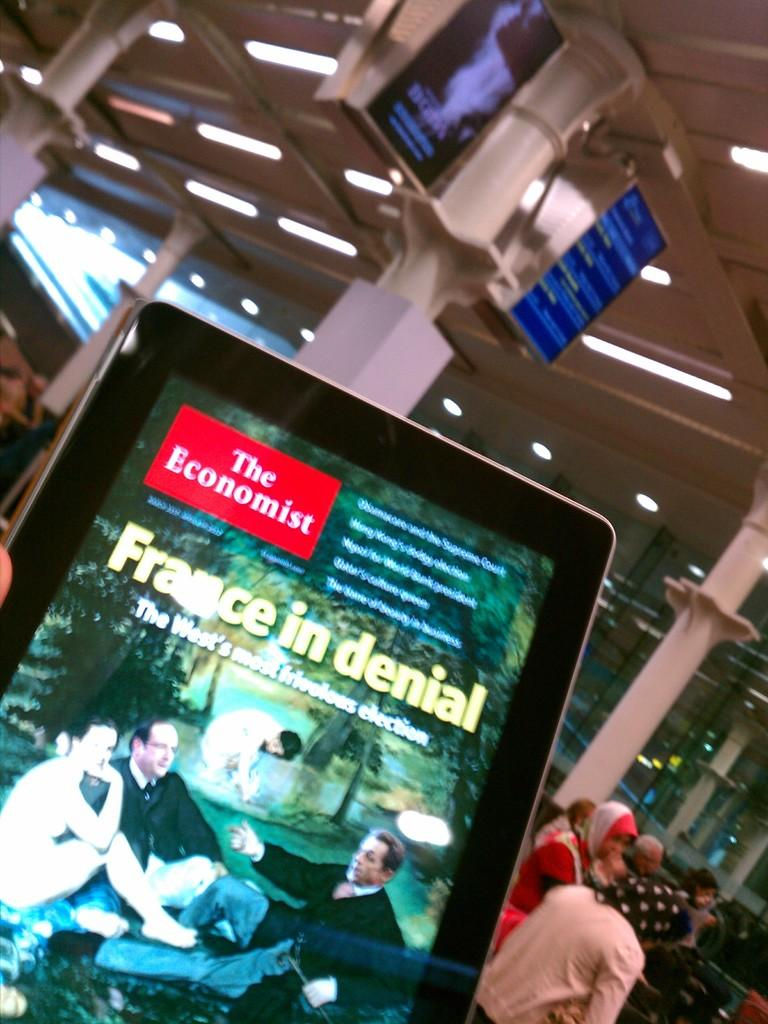What is the main object in the center of the image? There is a screen in the center of the image. What can be seen in the background of the image? There are screens, pillars, persons, chairs, and lights in the background of the image. What type of summer distribution meeting is taking place in the image? There is no reference to a summer distribution meeting in the image; it only features screens, pillars, persons, chairs, and lights in the background. 